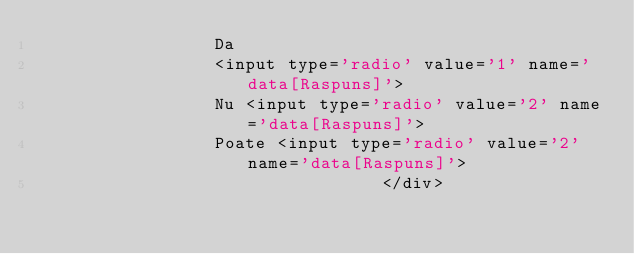Convert code to text. <code><loc_0><loc_0><loc_500><loc_500><_PHP_>                 Da   
                 <input type='radio' value='1' name='data[Raspuns]'>
                 Nu <input type='radio' value='2' name='data[Raspuns]'>
                 Poate <input type='radio' value='2' name='data[Raspuns]'>
                                 </div></code> 